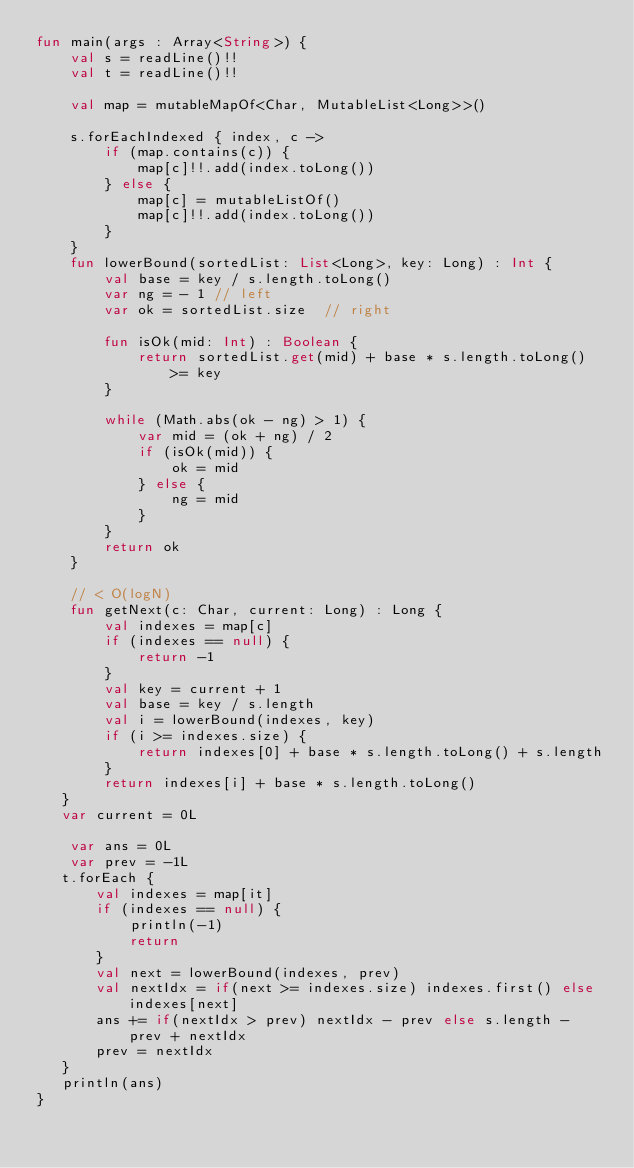Convert code to text. <code><loc_0><loc_0><loc_500><loc_500><_Kotlin_>fun main(args : Array<String>) {
    val s = readLine()!!
    val t = readLine()!!

    val map = mutableMapOf<Char, MutableList<Long>>()

    s.forEachIndexed { index, c ->
        if (map.contains(c)) {
            map[c]!!.add(index.toLong())
        } else {
            map[c] = mutableListOf()
            map[c]!!.add(index.toLong())
        }
    }
    fun lowerBound(sortedList: List<Long>, key: Long) : Int {
        val base = key / s.length.toLong()
        var ng = - 1 // left
        var ok = sortedList.size  // right

        fun isOk(mid: Int) : Boolean {
            return sortedList.get(mid) + base * s.length.toLong() >= key
        }

        while (Math.abs(ok - ng) > 1) {
            var mid = (ok + ng) / 2
            if (isOk(mid)) {
                ok = mid
            } else {
                ng = mid
            }
        }
        return ok
    }

    // < O(logN)
    fun getNext(c: Char, current: Long) : Long {
        val indexes = map[c]
        if (indexes == null) {
            return -1
        }
        val key = current + 1
        val base = key / s.length
        val i = lowerBound(indexes, key)
        if (i >= indexes.size) {
            return indexes[0] + base * s.length.toLong() + s.length
        }
        return indexes[i] + base * s.length.toLong()
   }
   var current = 0L

    var ans = 0L
    var prev = -1L
   t.forEach {
       val indexes = map[it]
       if (indexes == null) {
           println(-1)
           return
       }
       val next = lowerBound(indexes, prev)
       val nextIdx = if(next >= indexes.size) indexes.first() else indexes[next]
       ans += if(nextIdx > prev) nextIdx - prev else s.length - prev + nextIdx
       prev = nextIdx
   }
   println(ans)
}</code> 